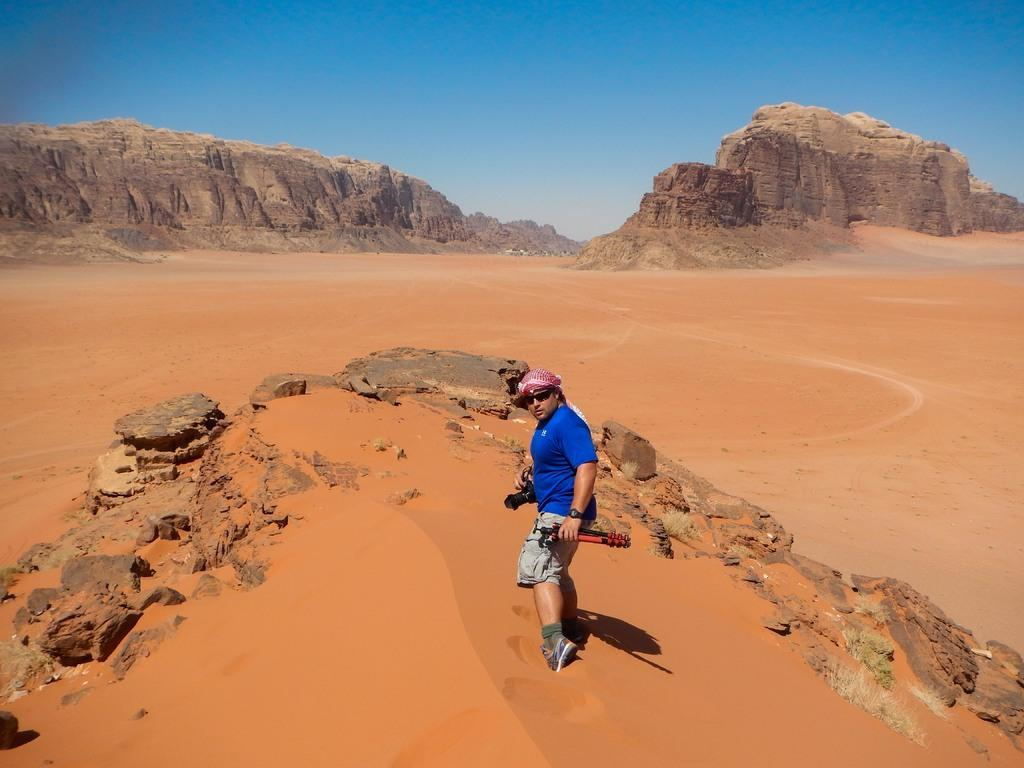What is the person in the image wearing? The person is wearing a blue shirt in the image. What is the person's posture in the image? The person is standing in the image. What type of terrain can be seen in the background of the image? There is sand in the background of the image. What geological features are present in the background of the image? There are two rock mountains in the background of the image. What type of nail can be seen in the person's hand in the image? There is no nail visible in the person's hand in the image. What type of marble is present in the image? There is no marble present in the image. 